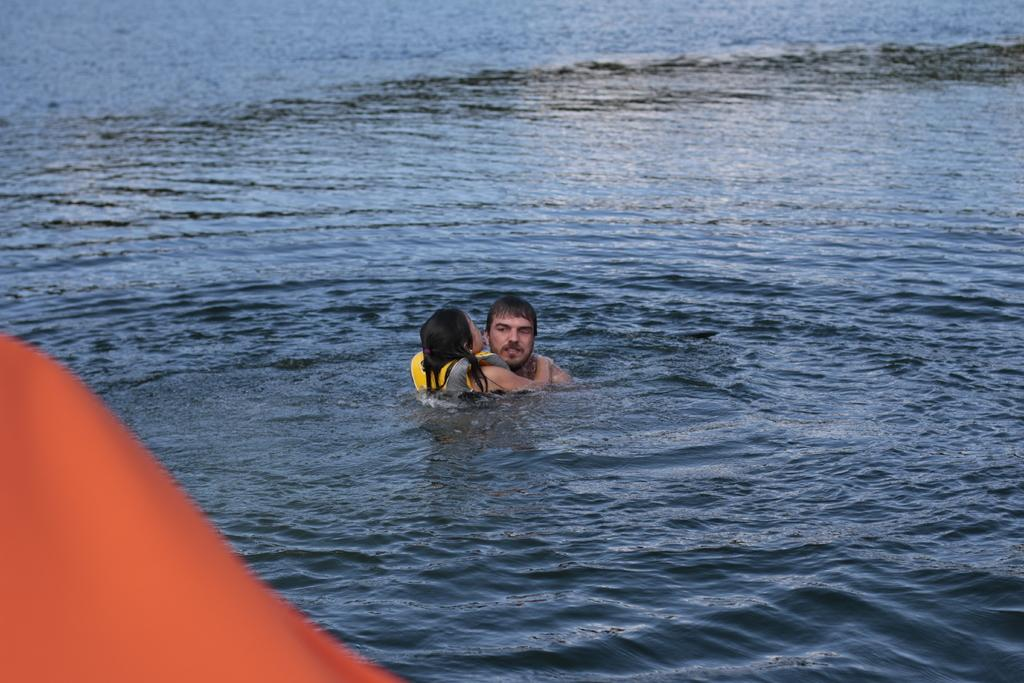What are the people in the image doing? The people in the image are in the water. Can you describe the attire of one of the individuals in the water? One person is wearing a life jacket. How many women are participating in the bone-collecting event in the image? There is no mention of women or a bone-collecting event in the image; it features people in the water, and one person is wearing a life jacket. 